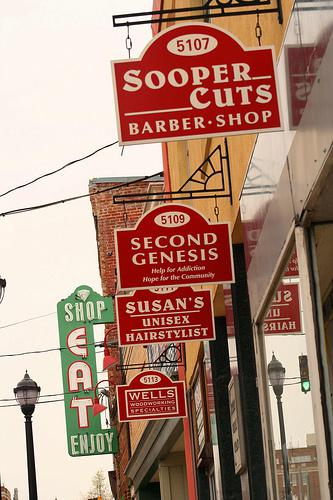Question: what is hanging for the buildings?
Choices:
A. A clock.
B. Banners.
C. Lamps.
D. Signs.
Answer with the letter. Answer: D Question: when was the photo taken?
Choices:
A. A field.
B. A city.
C. A park.
D. A concert.
Answer with the letter. Answer: B Question: what ws the sky?
Choices:
A. Blue.
B. Red.
C. Grey.
D. White.
Answer with the letter. Answer: D 